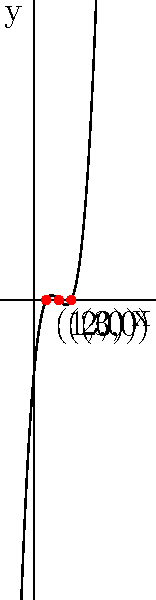As an endocrinologist, you're studying a hormone production rate model represented by the polynomial function $f(x) = x^3 - 6x^2 + 11x - 6$, where $x$ is time in hours and $f(x)$ is the production rate in ng/mL/hr. The graph of this function is shown above. What are the roots of this polynomial equation, and what do they signify in terms of hormone production? To solve this problem, we'll follow these steps:

1) From the graph, we can see that the polynomial crosses the x-axis at three points: (1,0), (2,0), and (3,0). These are the roots of the polynomial.

2) To verify algebraically:
   $f(x) = x^3 - 6x^2 + 11x - 6$
   $= (x-1)(x-2)(x-3)$

3) When we set $f(x) = 0$, we get:
   $(x-1)(x-2)(x-3) = 0$

4) This is true when $x = 1$, $x = 2$, or $x = 3$, confirming our graphical observation.

5) In the context of hormone production:
   - The roots represent the times (in hours) when the hormone production rate is zero.
   - At 1 hour, 2 hours, and 3 hours after the start of observation, the hormone production rate crosses zero.

6) This could indicate:
   - The hormone production rate changes from positive to negative (or vice versa) at these times.
   - There might be a cyclical nature to the hormone production, with periods of production followed by periods of absorption or breakdown.
Answer: Roots: 1, 2, and 3 hours. They represent times when hormone production rate is zero, indicating transitions in production/absorption cycles. 